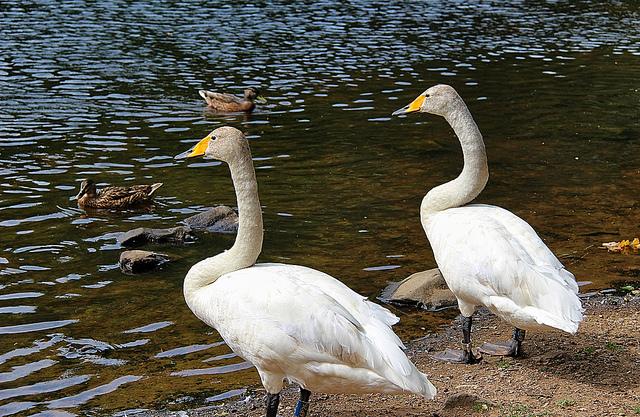What is the two birds called?
Short answer required. Geese. What is in the water with the ducks?
Answer briefly. Rocks. Is it sunny?
Be succinct. Yes. 